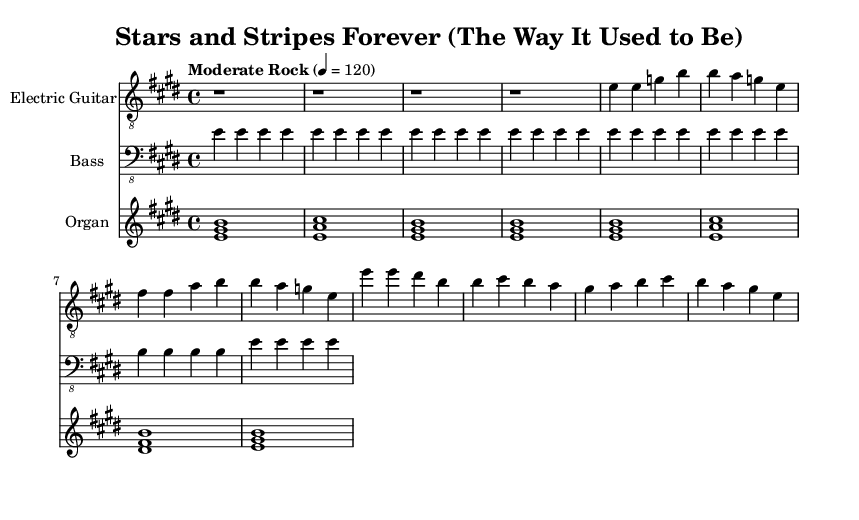What is the key signature of this music? The key signature is E major, which has four sharps (F#, C#, G#, D#). This can be seen at the beginning of the staff where the sharps are indicated.
Answer: E major What is the time signature of this music? The time signature is 4/4, as indicated right after the key signature at the beginning of the score. This means there are four beats per measure.
Answer: 4/4 What tempo marking is given for this piece? The tempo marking is "Moderate Rock" at a speed of 120 beats per minute, which is shown right before the musical staff in the tempo indication.
Answer: Moderate Rock What instrument is primarily playing the melody? The melody is being primarily played by the electric guitar, as indicated at the top of the respective staff.
Answer: Electric Guitar How many measures are in the electric guitar part? The electric guitar part contains a total of 16 measures, which can be counted based on the number of vertical lines (bar lines) dividing the music into sections.
Answer: 16 What are the first two notes played by the electric guitar? The first two notes played by the electric guitar are E and E, which can be seen in the opening measures of the guitar part.
Answer: E, E Which chords are played on the Hammond organ during the piece? The chords played on the Hammond organ include E major, A major, and D# minor. These chords are shown by the grouped notes in the organ staff, indicating harmonic structure.
Answer: E major, A major, D# minor 